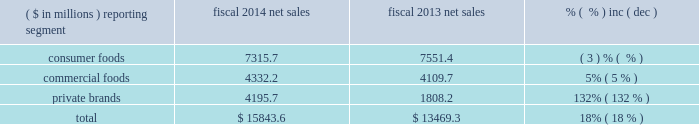Equity method investment earnings we include our share of the earnings of certain affiliates based on our economic ownership interest in the affiliates .
Significant affiliates include the ardent mills joint venture and affiliates that produce and market potato products for retail and foodservice customers .
Our share of earnings from our equity method investments was $ 122.1 million ( $ 119.1 million in the commercial foods segment and $ 3.0 million in the consumer foods segment ) and $ 32.5 million ( $ 29.7 million in the commercial foods segment and $ 2.8 million in the consumer foods segment ) in fiscal 2015 and 2014 , respectively .
The increase in fiscal 2015 compared to fiscal 2014 reflects the earnings from the ardent mills joint venture as well as higher profits for an international potato joint venture .
The earnings from the ardent mills joint venture reflect results for 11 months of operations , as we recognize earnings on a one-month lag , due to differences in fiscal year periods .
In fiscal 2014 , earnings also reflected a $ 3.4 million charge reflecting the year-end write-off of actuarial losses in excess of 10% ( 10 % ) of the pension liability for an international potato venture .
Results of discontinued operations our discontinued operations generated after-tax income of $ 366.6 million and $ 141.4 million in fiscal 2015 and 2014 , respectively .
The results of discontinued operations for fiscal 2015 include a pre-tax gain of $ 625.6 million ( $ 379.6 million after-tax ) recognized on the formation of the ardent mills joint venture .
The results for fiscal 2014 reflect a pre-tax gain of $ 90.0 million ( $ 55.7 million after-tax ) related to the disposition of three flour milling facilities as part of the ardent mills formation .
In fiscal 2014 , we also completed the sale of a small snack business , medallion foods , for $ 32.0 million in cash .
We recognized an after-tax loss of $ 3.5 million on the sale of this business in fiscal 2014 .
In fiscal 2014 , we recognized an impairment charge related to allocated amounts of goodwill and intangible assets , totaling $ 15.2 million after-tax , in anticipation of this divestiture .
We also completed the sale of the assets of the lightlife ae business for $ 54.7 million in cash .
We recognized an after-tax gain of $ 19.8 million on the sale of this business in fiscal 2014 .
Earnings ( loss ) per share diluted loss per share in fiscal 2015 was $ 0.60 , including a loss of $ 1.46 per diluted share from continuing operations and earnings of $ 0.86 per diluted share from discontinued operations .
Diluted earnings per share in fiscal 2014 were $ 0.70 , including $ 0.37 per diluted share from continuing operations and $ 0.33 per diluted share from discontinued operations .
See 201citems impacting comparability 201d above as several significant items affected the comparability of year-over-year results of operations .
Fiscal 2014 compared to fiscal 2013 net sales ( $ in millions ) reporting segment fiscal 2014 net sales fiscal 2013 net sales .
Overall , our net sales increased $ 2.37 billion to $ 15.84 billion in fiscal 2014 compared to fiscal 2013 , primarily related to the acquisition of ralcorp .
Consumer foods net sales for fiscal 2014 were $ 7.32 billion , a decrease of $ 235.7 million , or 3% ( 3 % ) , compared to fiscal 2013 .
Results reflected a 3% ( 3 % ) decrease in volume performance and a 1% ( 1 % ) decrease due to the impact of foreign exchange rates , partially offset by a 1% ( 1 % ) increase in price/mix .
Volume performance from our base businesses for fiscal 2014 was impacted negatively by competitor promotional activity .
Significant slotting and promotion investments related to new product launches , particularly in the first quarter , also weighed heavily on net sales in fiscal 2014 .
In addition , certain shipments planned for the fourth quarter of fiscal 2014 were shifted to the first quarter of fiscal 2015 as a result of change in timing of retailer promotions and this negatively impacted volume performance. .
What percent of net sales in fiscal 2013 where due to private brands? 
Computations: (1808.2 / 13469.3)
Answer: 0.13425. 